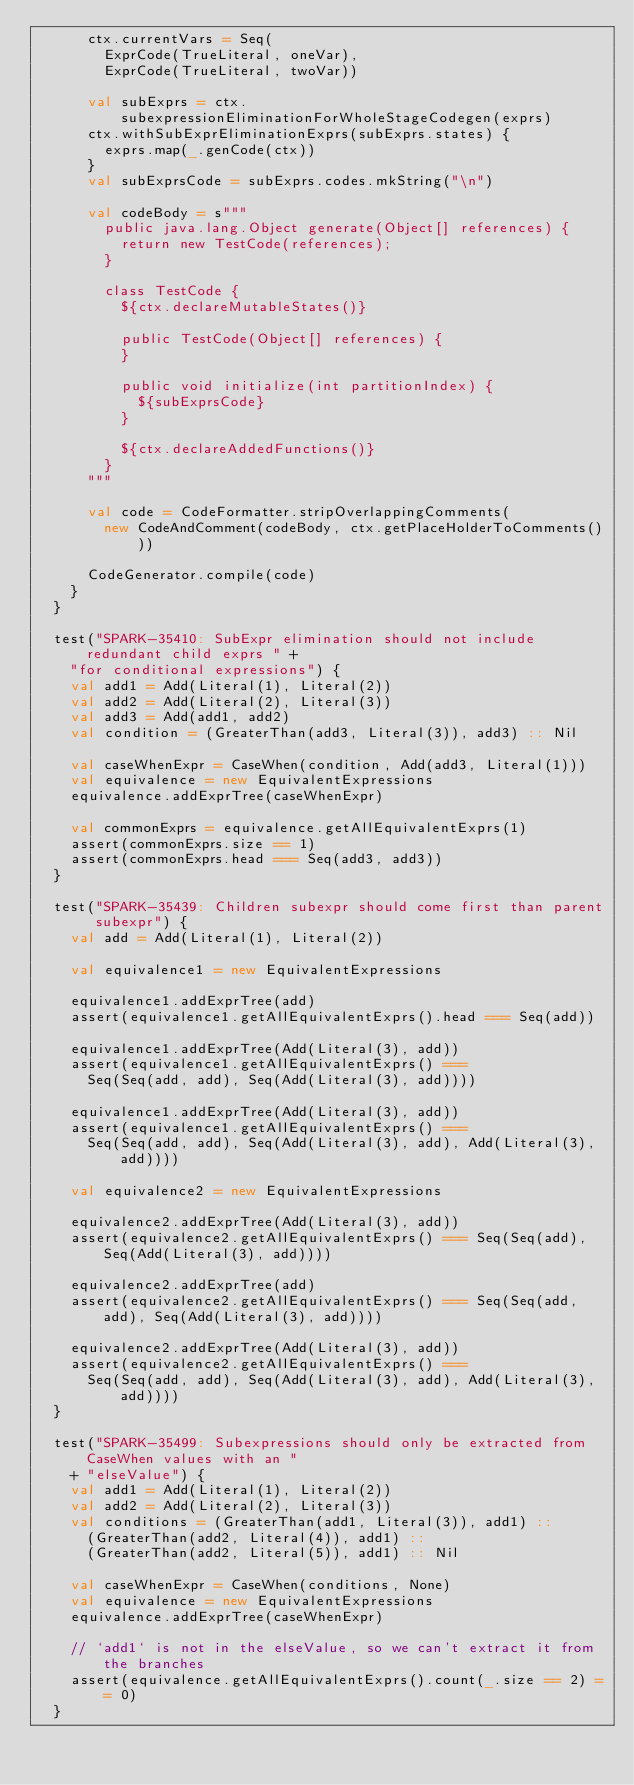<code> <loc_0><loc_0><loc_500><loc_500><_Scala_>      ctx.currentVars = Seq(
        ExprCode(TrueLiteral, oneVar),
        ExprCode(TrueLiteral, twoVar))

      val subExprs = ctx.subexpressionEliminationForWholeStageCodegen(exprs)
      ctx.withSubExprEliminationExprs(subExprs.states) {
        exprs.map(_.genCode(ctx))
      }
      val subExprsCode = subExprs.codes.mkString("\n")

      val codeBody = s"""
        public java.lang.Object generate(Object[] references) {
          return new TestCode(references);
        }

        class TestCode {
          ${ctx.declareMutableStates()}

          public TestCode(Object[] references) {
          }

          public void initialize(int partitionIndex) {
            ${subExprsCode}
          }

          ${ctx.declareAddedFunctions()}
        }
      """

      val code = CodeFormatter.stripOverlappingComments(
        new CodeAndComment(codeBody, ctx.getPlaceHolderToComments()))

      CodeGenerator.compile(code)
    }
  }

  test("SPARK-35410: SubExpr elimination should not include redundant child exprs " +
    "for conditional expressions") {
    val add1 = Add(Literal(1), Literal(2))
    val add2 = Add(Literal(2), Literal(3))
    val add3 = Add(add1, add2)
    val condition = (GreaterThan(add3, Literal(3)), add3) :: Nil

    val caseWhenExpr = CaseWhen(condition, Add(add3, Literal(1)))
    val equivalence = new EquivalentExpressions
    equivalence.addExprTree(caseWhenExpr)

    val commonExprs = equivalence.getAllEquivalentExprs(1)
    assert(commonExprs.size == 1)
    assert(commonExprs.head === Seq(add3, add3))
  }

  test("SPARK-35439: Children subexpr should come first than parent subexpr") {
    val add = Add(Literal(1), Literal(2))

    val equivalence1 = new EquivalentExpressions

    equivalence1.addExprTree(add)
    assert(equivalence1.getAllEquivalentExprs().head === Seq(add))

    equivalence1.addExprTree(Add(Literal(3), add))
    assert(equivalence1.getAllEquivalentExprs() ===
      Seq(Seq(add, add), Seq(Add(Literal(3), add))))

    equivalence1.addExprTree(Add(Literal(3), add))
    assert(equivalence1.getAllEquivalentExprs() ===
      Seq(Seq(add, add), Seq(Add(Literal(3), add), Add(Literal(3), add))))

    val equivalence2 = new EquivalentExpressions

    equivalence2.addExprTree(Add(Literal(3), add))
    assert(equivalence2.getAllEquivalentExprs() === Seq(Seq(add), Seq(Add(Literal(3), add))))

    equivalence2.addExprTree(add)
    assert(equivalence2.getAllEquivalentExprs() === Seq(Seq(add, add), Seq(Add(Literal(3), add))))

    equivalence2.addExprTree(Add(Literal(3), add))
    assert(equivalence2.getAllEquivalentExprs() ===
      Seq(Seq(add, add), Seq(Add(Literal(3), add), Add(Literal(3), add))))
  }

  test("SPARK-35499: Subexpressions should only be extracted from CaseWhen values with an "
    + "elseValue") {
    val add1 = Add(Literal(1), Literal(2))
    val add2 = Add(Literal(2), Literal(3))
    val conditions = (GreaterThan(add1, Literal(3)), add1) ::
      (GreaterThan(add2, Literal(4)), add1) ::
      (GreaterThan(add2, Literal(5)), add1) :: Nil

    val caseWhenExpr = CaseWhen(conditions, None)
    val equivalence = new EquivalentExpressions
    equivalence.addExprTree(caseWhenExpr)

    // `add1` is not in the elseValue, so we can't extract it from the branches
    assert(equivalence.getAllEquivalentExprs().count(_.size == 2) == 0)
  }</code> 